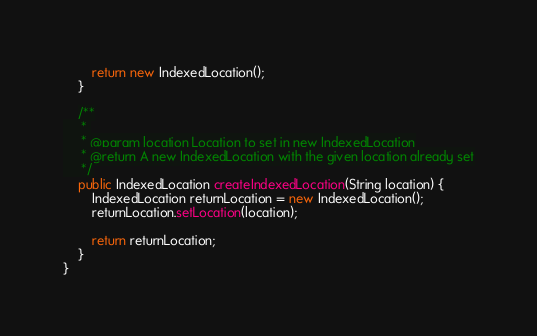<code> <loc_0><loc_0><loc_500><loc_500><_Java_>		return new IndexedLocation();
	}
	
    /**
     * 
     * @param location Location to set in new IndexedLocation
     * @return A new IndexedLocation with the given location already set
     */
	public IndexedLocation createIndexedLocation(String location) {
		IndexedLocation returnLocation = new IndexedLocation();
		returnLocation.setLocation(location);
		
		return returnLocation;
	}
}
</code> 